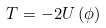<formula> <loc_0><loc_0><loc_500><loc_500>T = - 2 U \, ( \phi )</formula> 